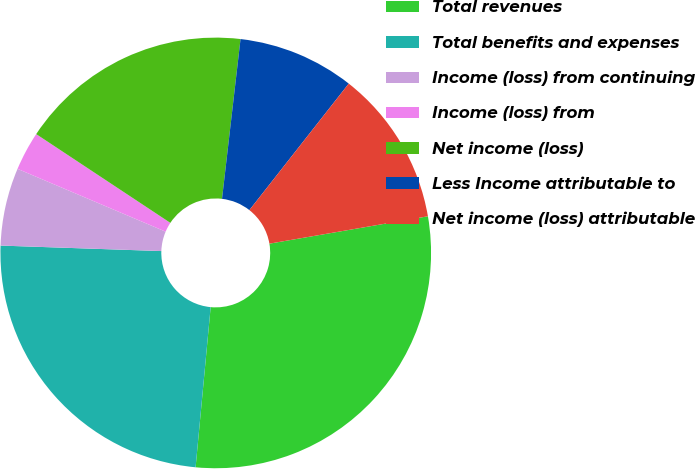Convert chart to OTSL. <chart><loc_0><loc_0><loc_500><loc_500><pie_chart><fcel>Total revenues<fcel>Total benefits and expenses<fcel>Income (loss) from continuing<fcel>Income (loss) from<fcel>Net income (loss)<fcel>Less Income attributable to<fcel>Net income (loss) attributable<nl><fcel>29.21%<fcel>24.05%<fcel>5.84%<fcel>2.92%<fcel>17.53%<fcel>8.76%<fcel>11.68%<nl></chart> 